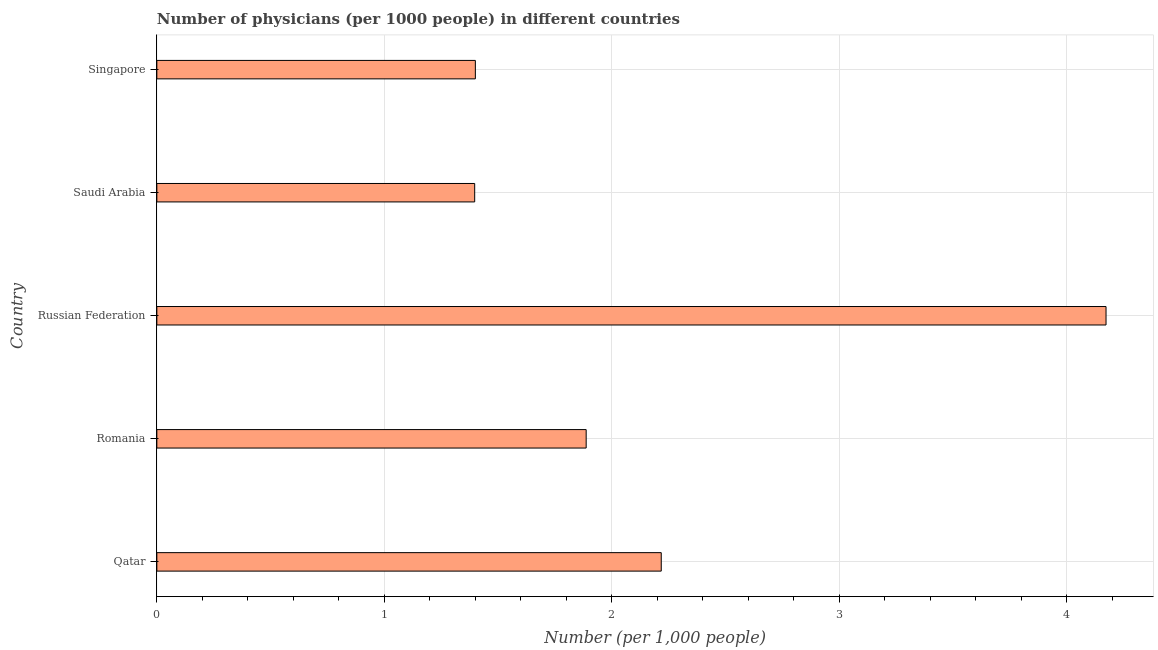What is the title of the graph?
Your answer should be very brief. Number of physicians (per 1000 people) in different countries. What is the label or title of the X-axis?
Offer a very short reply. Number (per 1,0 people). What is the label or title of the Y-axis?
Offer a terse response. Country. What is the number of physicians in Singapore?
Offer a terse response. 1.4. Across all countries, what is the maximum number of physicians?
Make the answer very short. 4.17. Across all countries, what is the minimum number of physicians?
Keep it short and to the point. 1.4. In which country was the number of physicians maximum?
Your response must be concise. Russian Federation. In which country was the number of physicians minimum?
Give a very brief answer. Saudi Arabia. What is the sum of the number of physicians?
Your response must be concise. 11.07. What is the difference between the number of physicians in Romania and Russian Federation?
Offer a terse response. -2.29. What is the average number of physicians per country?
Give a very brief answer. 2.21. What is the median number of physicians?
Ensure brevity in your answer.  1.89. What is the ratio of the number of physicians in Qatar to that in Russian Federation?
Your answer should be very brief. 0.53. Is the number of physicians in Saudi Arabia less than that in Singapore?
Make the answer very short. Yes. What is the difference between the highest and the second highest number of physicians?
Your answer should be very brief. 1.96. What is the difference between the highest and the lowest number of physicians?
Your answer should be compact. 2.77. How many bars are there?
Make the answer very short. 5. Are all the bars in the graph horizontal?
Your answer should be very brief. Yes. How many countries are there in the graph?
Your response must be concise. 5. What is the difference between two consecutive major ticks on the X-axis?
Provide a succinct answer. 1. What is the Number (per 1,000 people) of Qatar?
Make the answer very short. 2.22. What is the Number (per 1,000 people) in Romania?
Ensure brevity in your answer.  1.89. What is the Number (per 1,000 people) in Russian Federation?
Your answer should be very brief. 4.17. What is the Number (per 1,000 people) in Saudi Arabia?
Make the answer very short. 1.4. What is the Number (per 1,000 people) in Singapore?
Your answer should be compact. 1.4. What is the difference between the Number (per 1,000 people) in Qatar and Romania?
Your response must be concise. 0.33. What is the difference between the Number (per 1,000 people) in Qatar and Russian Federation?
Your answer should be compact. -1.96. What is the difference between the Number (per 1,000 people) in Qatar and Saudi Arabia?
Your response must be concise. 0.82. What is the difference between the Number (per 1,000 people) in Qatar and Singapore?
Your answer should be very brief. 0.82. What is the difference between the Number (per 1,000 people) in Romania and Russian Federation?
Keep it short and to the point. -2.29. What is the difference between the Number (per 1,000 people) in Romania and Saudi Arabia?
Offer a terse response. 0.49. What is the difference between the Number (per 1,000 people) in Romania and Singapore?
Keep it short and to the point. 0.49. What is the difference between the Number (per 1,000 people) in Russian Federation and Saudi Arabia?
Keep it short and to the point. 2.77. What is the difference between the Number (per 1,000 people) in Russian Federation and Singapore?
Give a very brief answer. 2.77. What is the difference between the Number (per 1,000 people) in Saudi Arabia and Singapore?
Your response must be concise. -0. What is the ratio of the Number (per 1,000 people) in Qatar to that in Romania?
Ensure brevity in your answer.  1.18. What is the ratio of the Number (per 1,000 people) in Qatar to that in Russian Federation?
Your answer should be very brief. 0.53. What is the ratio of the Number (per 1,000 people) in Qatar to that in Saudi Arabia?
Give a very brief answer. 1.59. What is the ratio of the Number (per 1,000 people) in Qatar to that in Singapore?
Offer a very short reply. 1.58. What is the ratio of the Number (per 1,000 people) in Romania to that in Russian Federation?
Your response must be concise. 0.45. What is the ratio of the Number (per 1,000 people) in Romania to that in Saudi Arabia?
Your answer should be compact. 1.35. What is the ratio of the Number (per 1,000 people) in Romania to that in Singapore?
Provide a succinct answer. 1.35. What is the ratio of the Number (per 1,000 people) in Russian Federation to that in Saudi Arabia?
Your response must be concise. 2.99. What is the ratio of the Number (per 1,000 people) in Russian Federation to that in Singapore?
Your answer should be very brief. 2.98. 